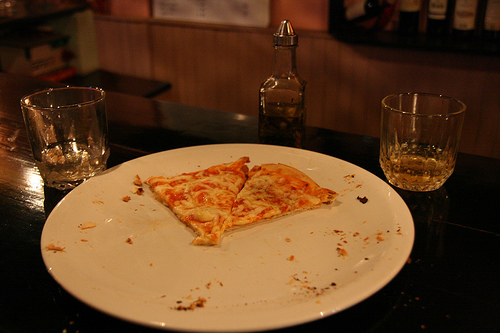Do you think the cheese is white or brown? The cheese on the pizza is white, adding a creamy appearance to the slices. 